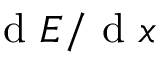<formula> <loc_0><loc_0><loc_500><loc_500>{ d } E / { d } x</formula> 